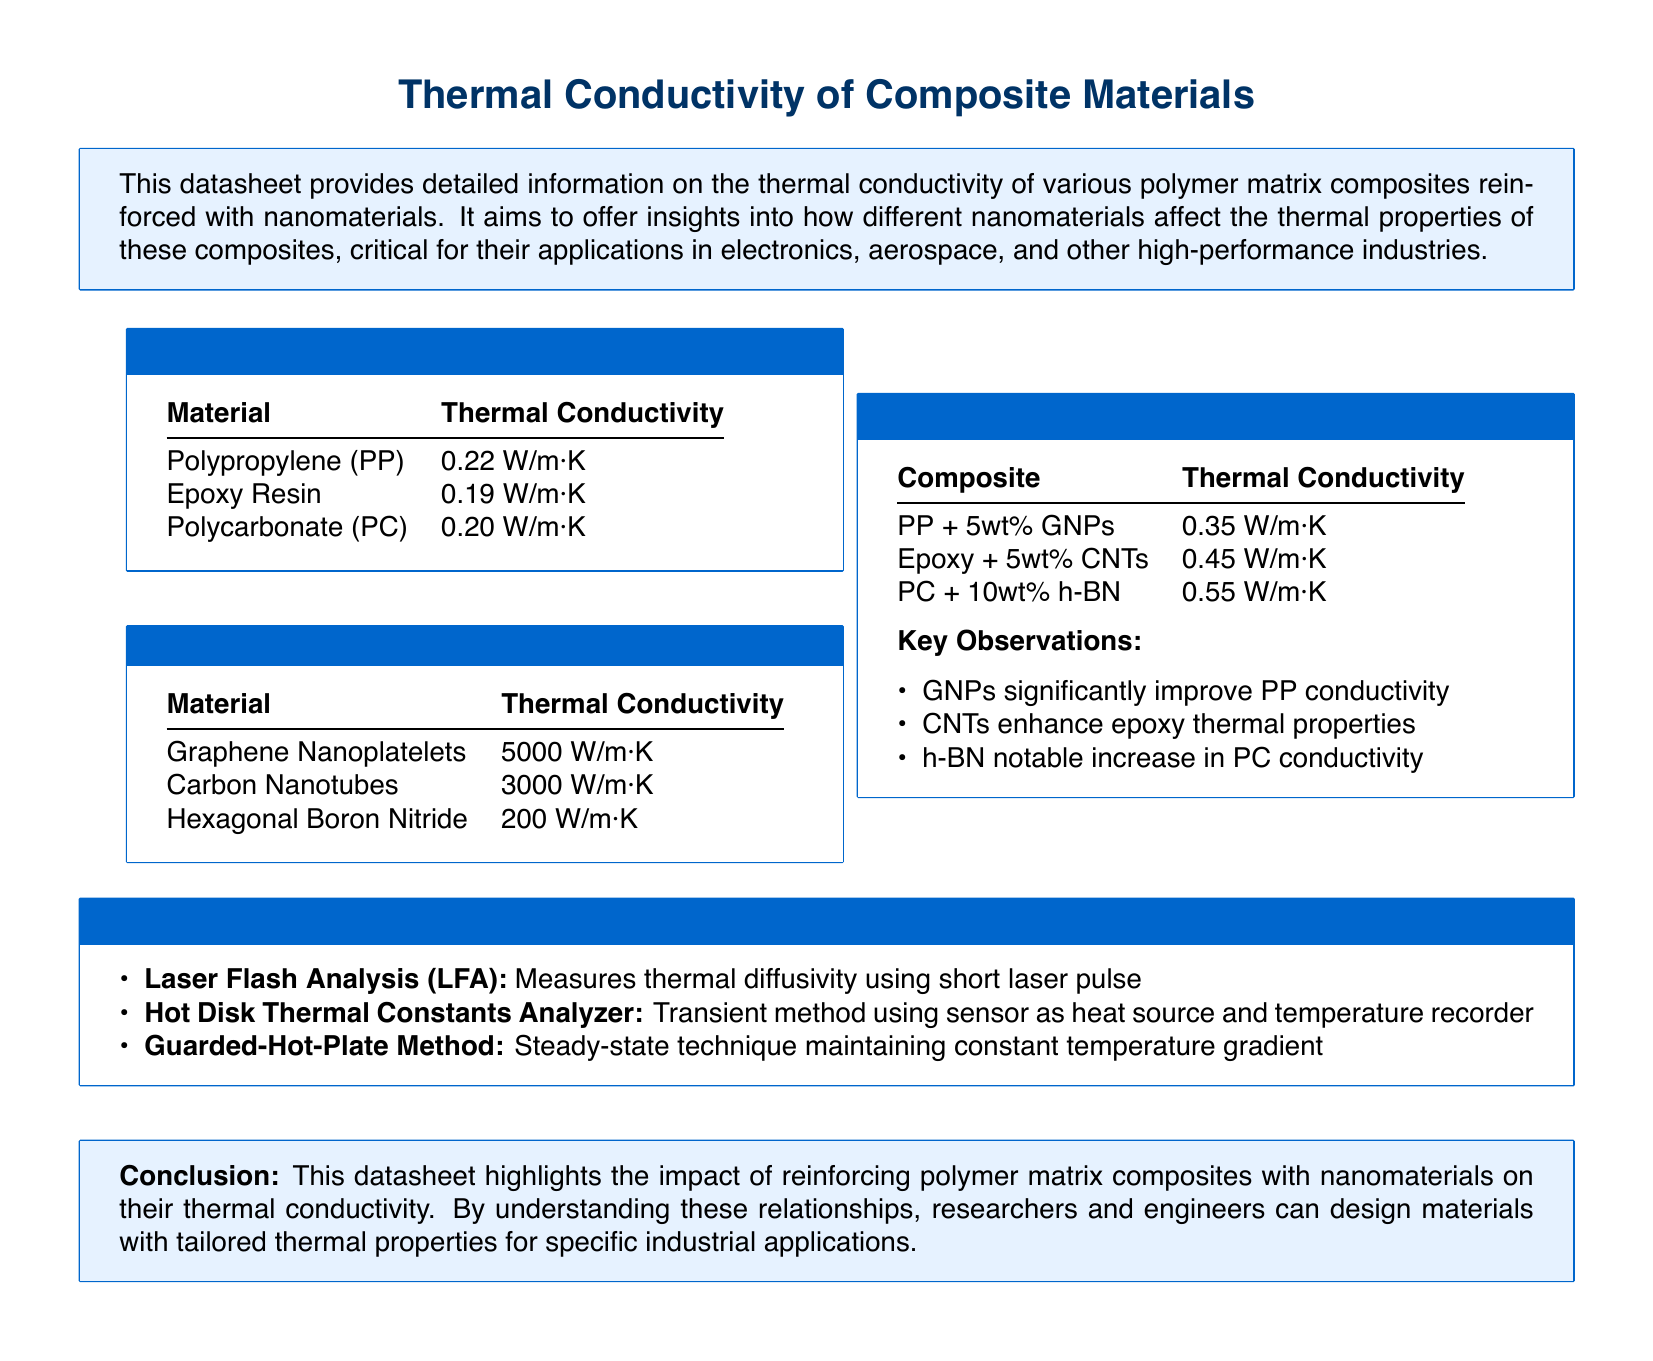What is the thermal conductivity of Polypropylene? The thermal conductivity of Polypropylene is listed in the document as 0.22 W/m·K.
Answer: 0.22 W/m·K What nanomaterial has the highest thermal conductivity? The document states that Graphene Nanoplatelets have the highest thermal conductivity at 5000 W/m·K.
Answer: 5000 W/m·K Which composite material has a thermal conductivity of 0.55 W/m·K? The composite with a thermal conductivity of 0.55 W/m·K is PC + 10wt% h-BN.
Answer: PC + 10wt% h-BN What method uses a short laser pulse for thermal conductivity measurements? The document refers to Laser Flash Analysis (LFA) as the method that uses a short laser pulse.
Answer: Laser Flash Analysis (LFA) What is a key observation about GNPs in the datasheet? The key observation mentioned is that GNPs significantly improve PP conductivity.
Answer: GNPs significantly improve PP conductivity What is the primary focus of the datasheet? The datasheet focuses on the thermal conductivity of polymer matrix composites reinforced with nanomaterials.
Answer: Thermal conductivity of polymer matrix composites reinforced with nanomaterials 